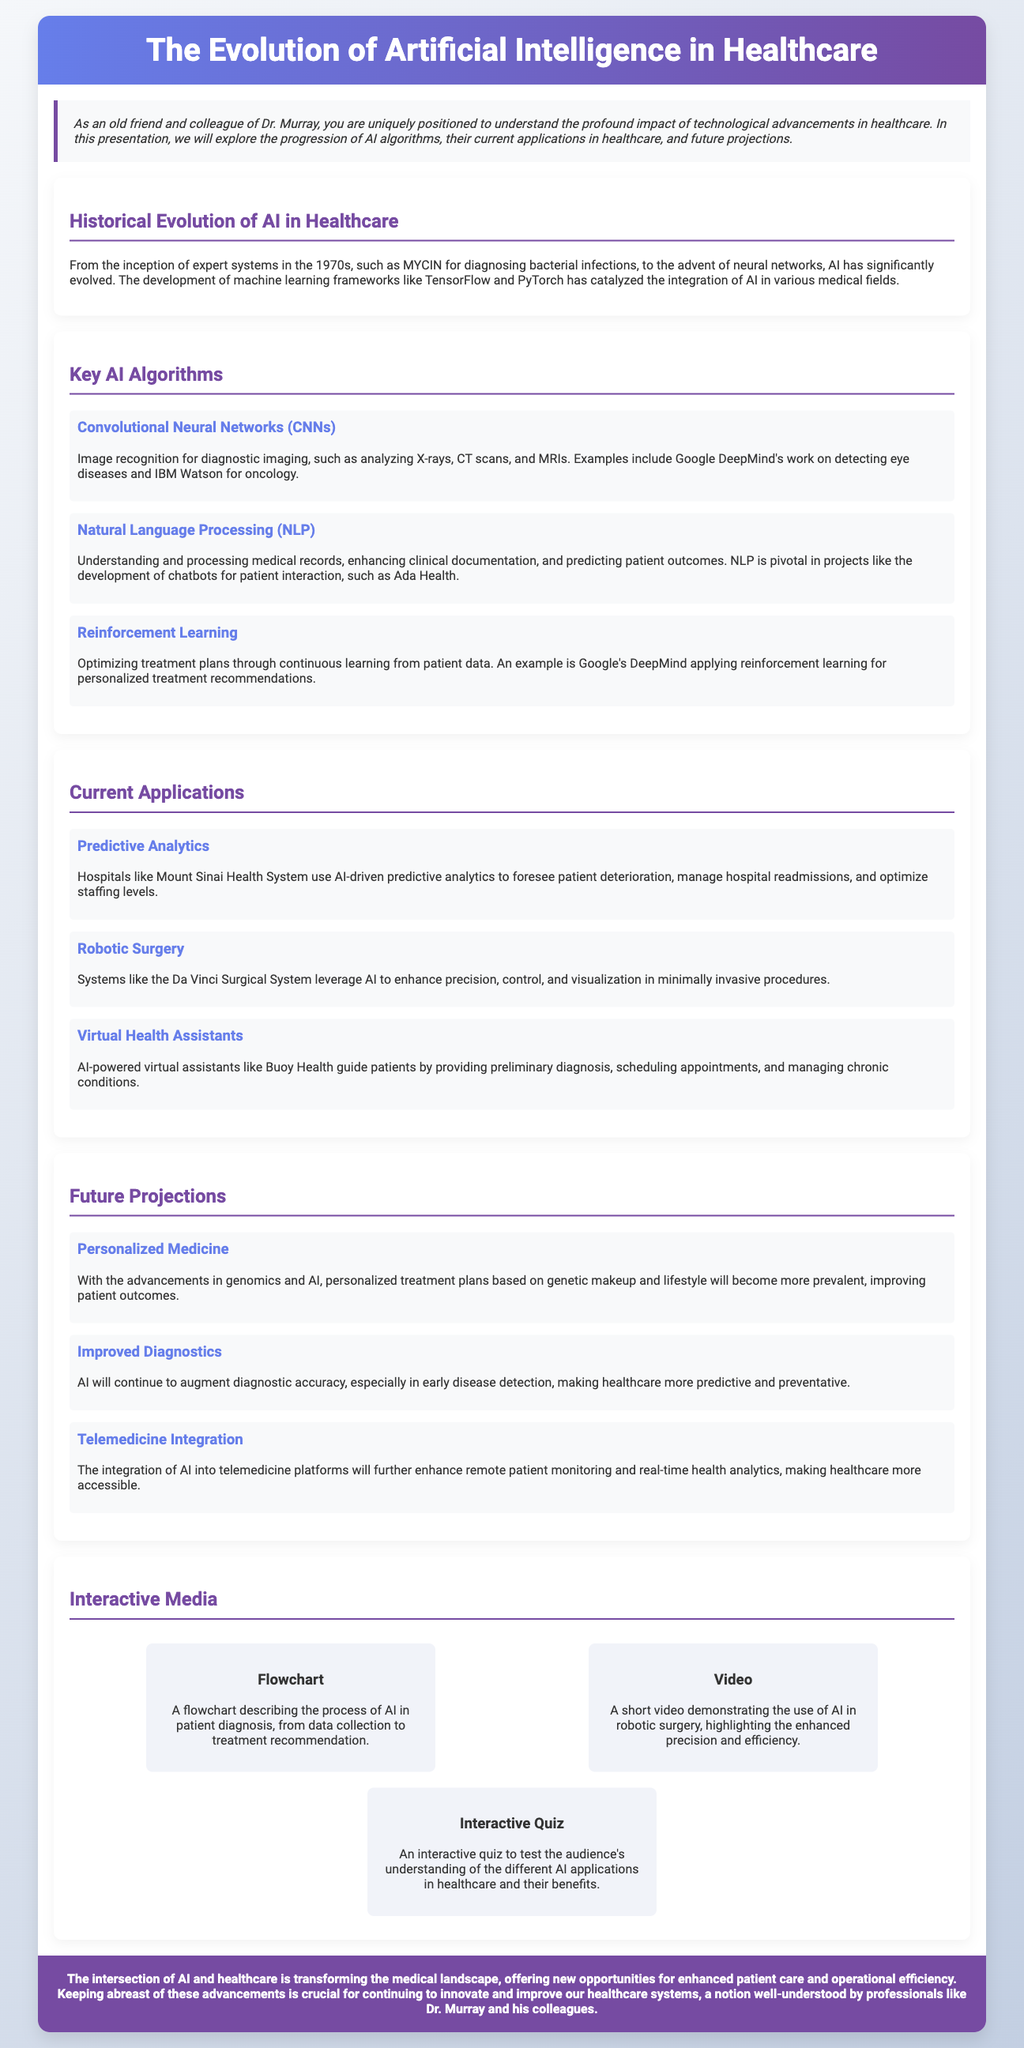What was the first AI system mentioned in healthcare? The document states that the first expert system in healthcare was MYCIN, developed in the 1970s for diagnosing bacterial infections.
Answer: MYCIN What are CNNs used for in healthcare? According to the presentation, CNNs are used for image recognition in diagnostic imaging such as analyzing X-rays, CT scans, and MRIs.
Answer: Image recognition Which AI algorithm helps in processing medical records? The document indicates that Natural Language Processing (NLP) is used for understanding and processing medical records.
Answer: Natural Language Processing What system is highlighted as leveraging AI in robotic surgery? The Da Vinci Surgical System is mentioned as a system that enhances precision and control in minimally invasive procedures.
Answer: Da Vinci Surgical System What is a future projection mentioned for AI in healthcare? The presentation describes personalized medicine as a future projection, which will tailor treatment plans based on genetic makeup and lifestyle.
Answer: Personalized Medicine Which hospital uses AI-driven predictive analytics? The document specifies that Mount Sinai Health System utilizes AI-driven predictive analytics.
Answer: Mount Sinai Health System What innovative media format is included in the presentation? The document features an interactive quiz designed to test the audience's understanding of AI applications in healthcare.
Answer: Interactive Quiz What year was MYCIN developed? The historical evolution section notes that MYCIN was developed in the 1970s.
Answer: 1970s Which algorithm applies reinforcement learning for personalized treatment? Google's DeepMind is mentioned as applying reinforcement learning for developing personalized treatment recommendations.
Answer: Google's DeepMind 